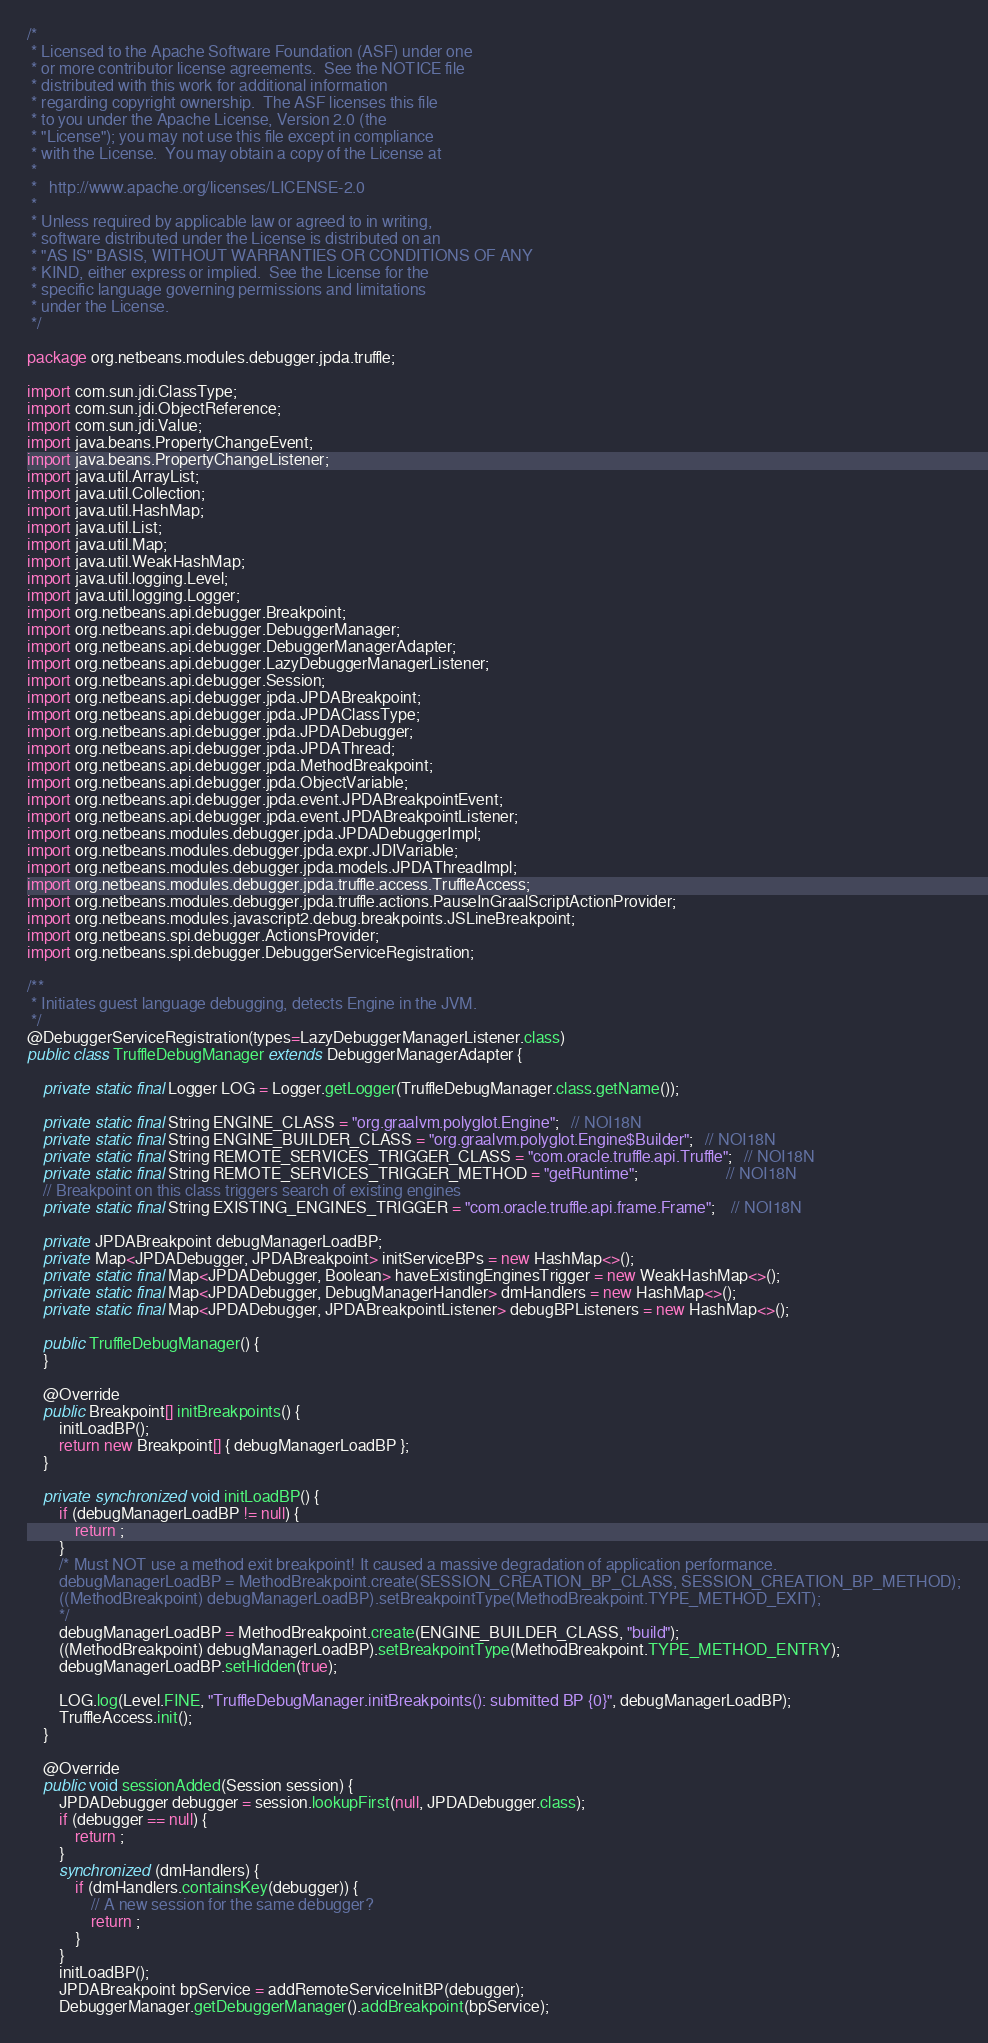Convert code to text. <code><loc_0><loc_0><loc_500><loc_500><_Java_>/*
 * Licensed to the Apache Software Foundation (ASF) under one
 * or more contributor license agreements.  See the NOTICE file
 * distributed with this work for additional information
 * regarding copyright ownership.  The ASF licenses this file
 * to you under the Apache License, Version 2.0 (the
 * "License"); you may not use this file except in compliance
 * with the License.  You may obtain a copy of the License at
 *
 *   http://www.apache.org/licenses/LICENSE-2.0
 *
 * Unless required by applicable law or agreed to in writing,
 * software distributed under the License is distributed on an
 * "AS IS" BASIS, WITHOUT WARRANTIES OR CONDITIONS OF ANY
 * KIND, either express or implied.  See the License for the
 * specific language governing permissions and limitations
 * under the License.
 */

package org.netbeans.modules.debugger.jpda.truffle;

import com.sun.jdi.ClassType;
import com.sun.jdi.ObjectReference;
import com.sun.jdi.Value;
import java.beans.PropertyChangeEvent;
import java.beans.PropertyChangeListener;
import java.util.ArrayList;
import java.util.Collection;
import java.util.HashMap;
import java.util.List;
import java.util.Map;
import java.util.WeakHashMap;
import java.util.logging.Level;
import java.util.logging.Logger;
import org.netbeans.api.debugger.Breakpoint;
import org.netbeans.api.debugger.DebuggerManager;
import org.netbeans.api.debugger.DebuggerManagerAdapter;
import org.netbeans.api.debugger.LazyDebuggerManagerListener;
import org.netbeans.api.debugger.Session;
import org.netbeans.api.debugger.jpda.JPDABreakpoint;
import org.netbeans.api.debugger.jpda.JPDAClassType;
import org.netbeans.api.debugger.jpda.JPDADebugger;
import org.netbeans.api.debugger.jpda.JPDAThread;
import org.netbeans.api.debugger.jpda.MethodBreakpoint;
import org.netbeans.api.debugger.jpda.ObjectVariable;
import org.netbeans.api.debugger.jpda.event.JPDABreakpointEvent;
import org.netbeans.api.debugger.jpda.event.JPDABreakpointListener;
import org.netbeans.modules.debugger.jpda.JPDADebuggerImpl;
import org.netbeans.modules.debugger.jpda.expr.JDIVariable;
import org.netbeans.modules.debugger.jpda.models.JPDAThreadImpl;
import org.netbeans.modules.debugger.jpda.truffle.access.TruffleAccess;
import org.netbeans.modules.debugger.jpda.truffle.actions.PauseInGraalScriptActionProvider;
import org.netbeans.modules.javascript2.debug.breakpoints.JSLineBreakpoint;
import org.netbeans.spi.debugger.ActionsProvider;
import org.netbeans.spi.debugger.DebuggerServiceRegistration;

/**
 * Initiates guest language debugging, detects Engine in the JVM.
 */
@DebuggerServiceRegistration(types=LazyDebuggerManagerListener.class)
public class TruffleDebugManager extends DebuggerManagerAdapter {
    
    private static final Logger LOG = Logger.getLogger(TruffleDebugManager.class.getName());
    
    private static final String ENGINE_CLASS = "org.graalvm.polyglot.Engine";   // NOI18N
    private static final String ENGINE_BUILDER_CLASS = "org.graalvm.polyglot.Engine$Builder";   // NOI18N
    private static final String REMOTE_SERVICES_TRIGGER_CLASS = "com.oracle.truffle.api.Truffle";   // NOI18N
    private static final String REMOTE_SERVICES_TRIGGER_METHOD = "getRuntime";                      // NOI18N
    // Breakpoint on this class triggers search of existing engines
    private static final String EXISTING_ENGINES_TRIGGER = "com.oracle.truffle.api.frame.Frame";    // NOI18N
    
    private JPDABreakpoint debugManagerLoadBP;
    private Map<JPDADebugger, JPDABreakpoint> initServiceBPs = new HashMap<>();
    private static final Map<JPDADebugger, Boolean> haveExistingEnginesTrigger = new WeakHashMap<>();
    private static final Map<JPDADebugger, DebugManagerHandler> dmHandlers = new HashMap<>();
    private static final Map<JPDADebugger, JPDABreakpointListener> debugBPListeners = new HashMap<>();
    
    public TruffleDebugManager() {
    }
    
    @Override
    public Breakpoint[] initBreakpoints() {
        initLoadBP();
        return new Breakpoint[] { debugManagerLoadBP };
    }
    
    private synchronized void initLoadBP() {
        if (debugManagerLoadBP != null) {
            return ;
        }
        /* Must NOT use a method exit breakpoint! It caused a massive degradation of application performance.
        debugManagerLoadBP = MethodBreakpoint.create(SESSION_CREATION_BP_CLASS, SESSION_CREATION_BP_METHOD);
        ((MethodBreakpoint) debugManagerLoadBP).setBreakpointType(MethodBreakpoint.TYPE_METHOD_EXIT);
        */
        debugManagerLoadBP = MethodBreakpoint.create(ENGINE_BUILDER_CLASS, "build");
        ((MethodBreakpoint) debugManagerLoadBP).setBreakpointType(MethodBreakpoint.TYPE_METHOD_ENTRY);
        debugManagerLoadBP.setHidden(true);
        
        LOG.log(Level.FINE, "TruffleDebugManager.initBreakpoints(): submitted BP {0}", debugManagerLoadBP);
        TruffleAccess.init();
    }

    @Override
    public void sessionAdded(Session session) {
        JPDADebugger debugger = session.lookupFirst(null, JPDADebugger.class);
        if (debugger == null) {
            return ;
        }
        synchronized (dmHandlers) {
            if (dmHandlers.containsKey(debugger)) {
                // A new session for the same debugger?
                return ;
            }
        }
        initLoadBP();
        JPDABreakpoint bpService = addRemoteServiceInitBP(debugger);
        DebuggerManager.getDebuggerManager().addBreakpoint(bpService);</code> 